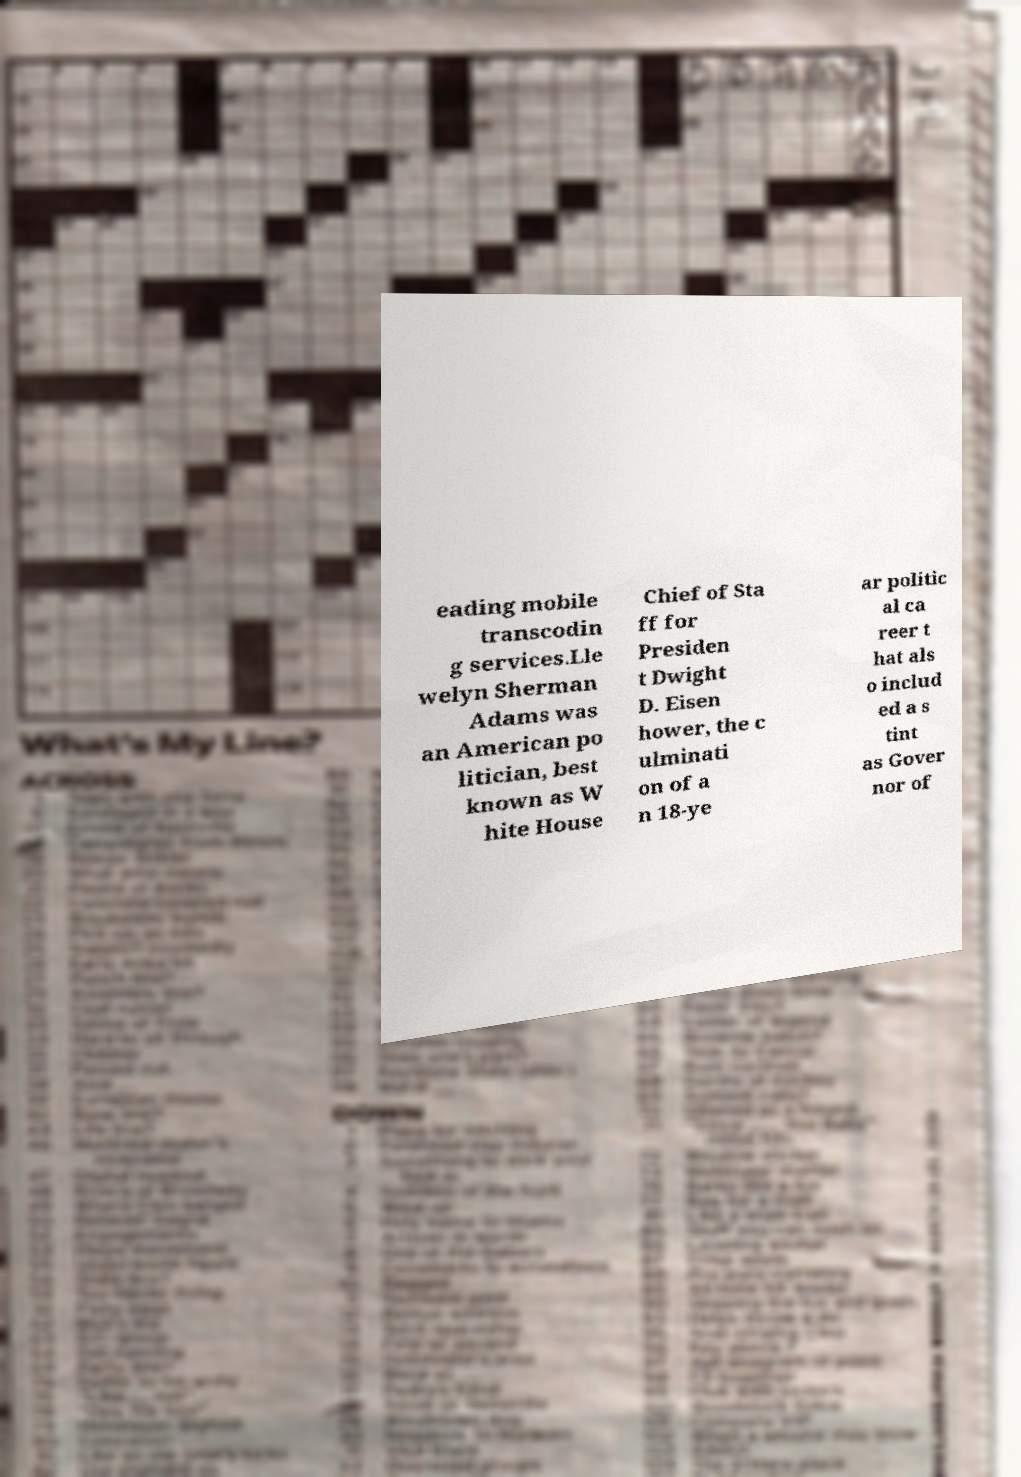Please read and relay the text visible in this image. What does it say? eading mobile transcodin g services.Lle welyn Sherman Adams was an American po litician, best known as W hite House Chief of Sta ff for Presiden t Dwight D. Eisen hower, the c ulminati on of a n 18-ye ar politic al ca reer t hat als o includ ed a s tint as Gover nor of 